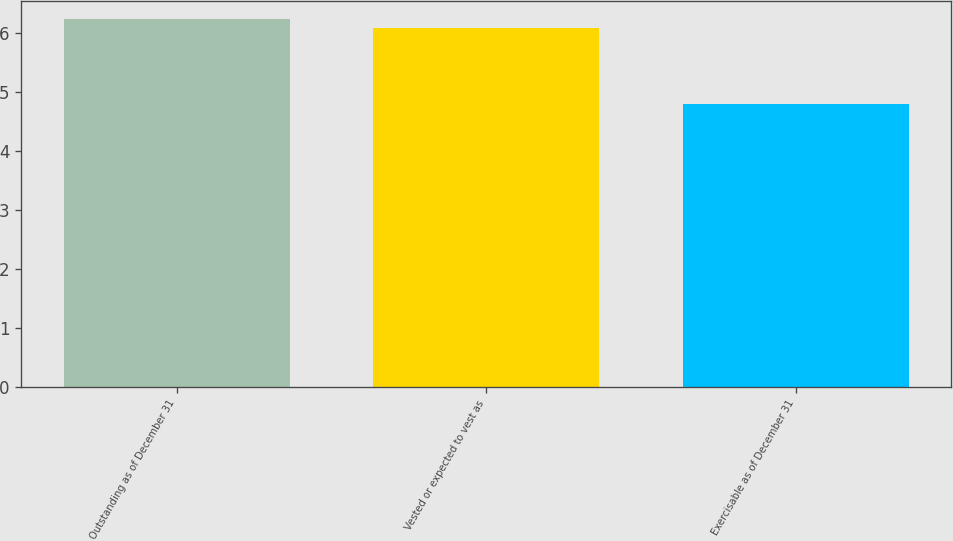<chart> <loc_0><loc_0><loc_500><loc_500><bar_chart><fcel>Outstanding as of December 31<fcel>Vested or expected to vest as<fcel>Exercisable as of December 31<nl><fcel>6.24<fcel>6.1<fcel>4.8<nl></chart> 